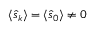Convert formula to latex. <formula><loc_0><loc_0><loc_500><loc_500>\langle \hat { s } _ { k } \rangle = \langle \hat { s } _ { 0 } \rangle \neq 0</formula> 